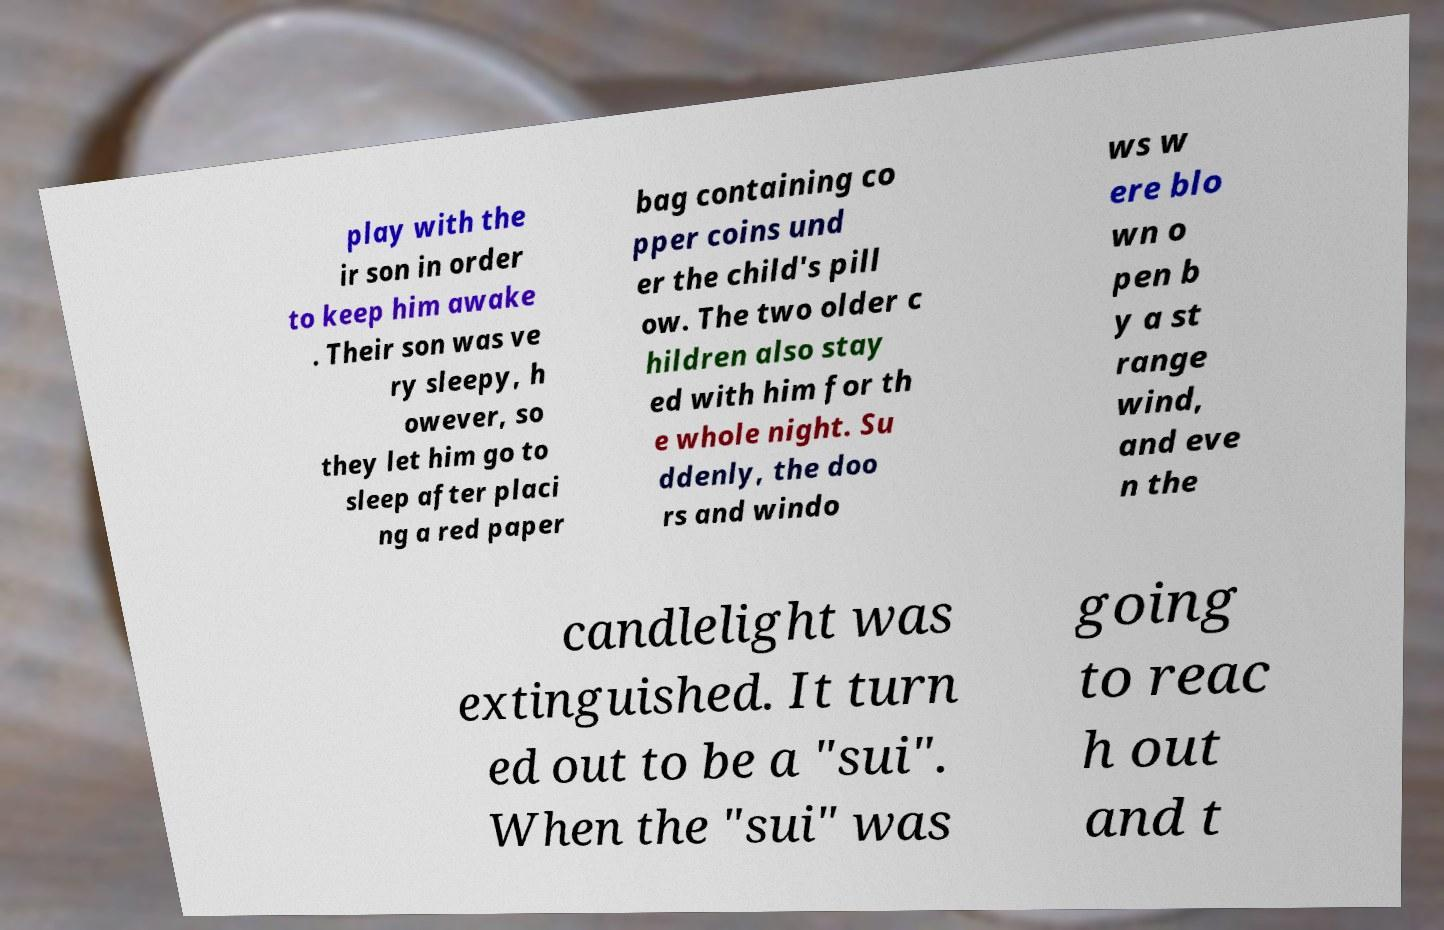Can you read and provide the text displayed in the image?This photo seems to have some interesting text. Can you extract and type it out for me? play with the ir son in order to keep him awake . Their son was ve ry sleepy, h owever, so they let him go to sleep after placi ng a red paper bag containing co pper coins und er the child's pill ow. The two older c hildren also stay ed with him for th e whole night. Su ddenly, the doo rs and windo ws w ere blo wn o pen b y a st range wind, and eve n the candlelight was extinguished. It turn ed out to be a "sui". When the "sui" was going to reac h out and t 